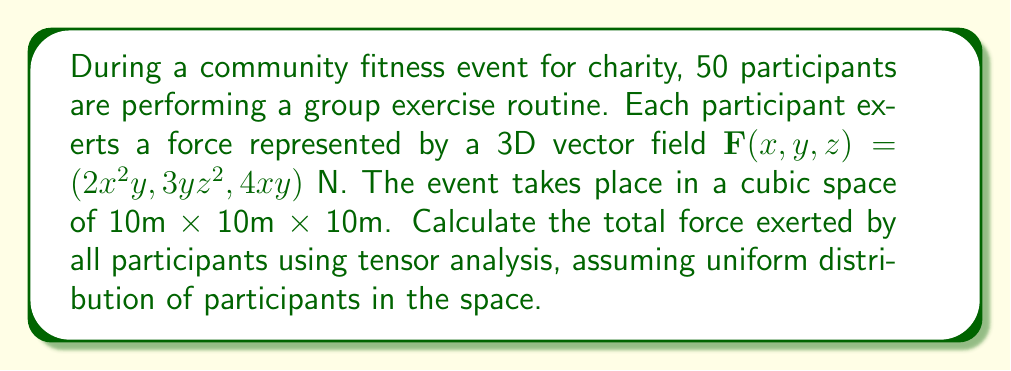Teach me how to tackle this problem. To solve this problem, we'll use tensor analysis and follow these steps:

1) First, we need to calculate the divergence of the force field:
   $$\nabla \cdot \mathbf{F} = \frac{\partial F_x}{\partial x} + \frac{\partial F_y}{\partial y} + \frac{\partial F_z}{\partial z}$$
   $$\nabla \cdot \mathbf{F} = \frac{\partial (2x^2y)}{\partial x} + \frac{\partial (3yz^2)}{\partial y} + \frac{\partial (4xy)}{\partial z}$$
   $$\nabla \cdot \mathbf{F} = 4xy + 3z^2 + 0 = 4xy + 3z^2$$

2) Now, we need to integrate this divergence over the volume to get the total force:
   $$\text{Total Force} = \iiint_V (\nabla \cdot \mathbf{F}) dV$$
   $$\text{Total Force} = \int_0^{10} \int_0^{10} \int_0^{10} (4xy + 3z^2) dx dy dz$$

3) Let's solve this triple integral:
   $$\text{Total Force} = \int_0^{10} \int_0^{10} [2x^2y]_0^{10} dy dz + \int_0^{10} \int_0^{10} [z^3]_0^{10} dx dy$$
   $$\text{Total Force} = \int_0^{10} [100y]_0^{10} dz + \int_0^{10} [1000]_0^{10} dy$$
   $$\text{Total Force} = [1000z]_0^{10} + [10000]_0^{10}$$
   $$\text{Total Force} = 10000 + 10000 = 20000 \text{ N}$$

4) This is the force exerted by one participant. For 50 participants:
   $$\text{Total Force} = 50 \times 20000 = 1,000,000 \text{ N}$$
Answer: 1,000,000 N 